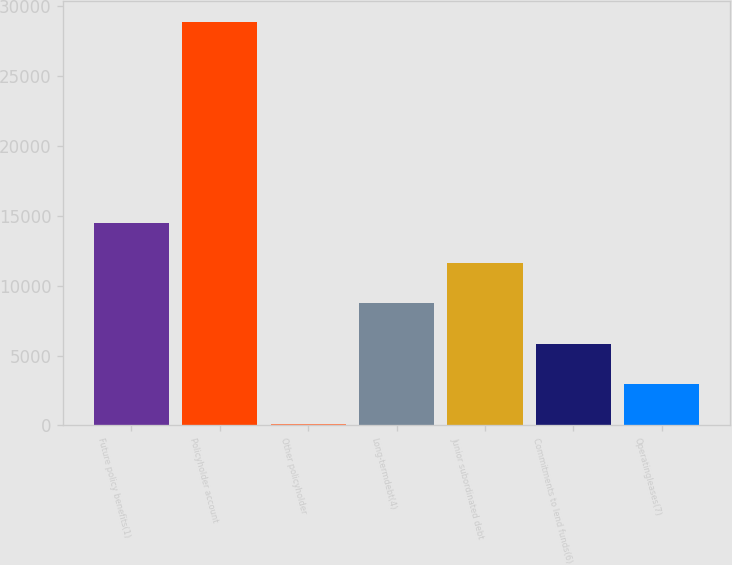Convert chart. <chart><loc_0><loc_0><loc_500><loc_500><bar_chart><fcel>Future policy benefits(1)<fcel>Policyholder account<fcel>Other policyholder<fcel>Long-termdebt(4)<fcel>Junior subordinated debt<fcel>Commitments to lend funds(6)<fcel>Operatingleases(7)<nl><fcel>14489<fcel>28884<fcel>94<fcel>8731<fcel>11610<fcel>5852<fcel>2973<nl></chart> 